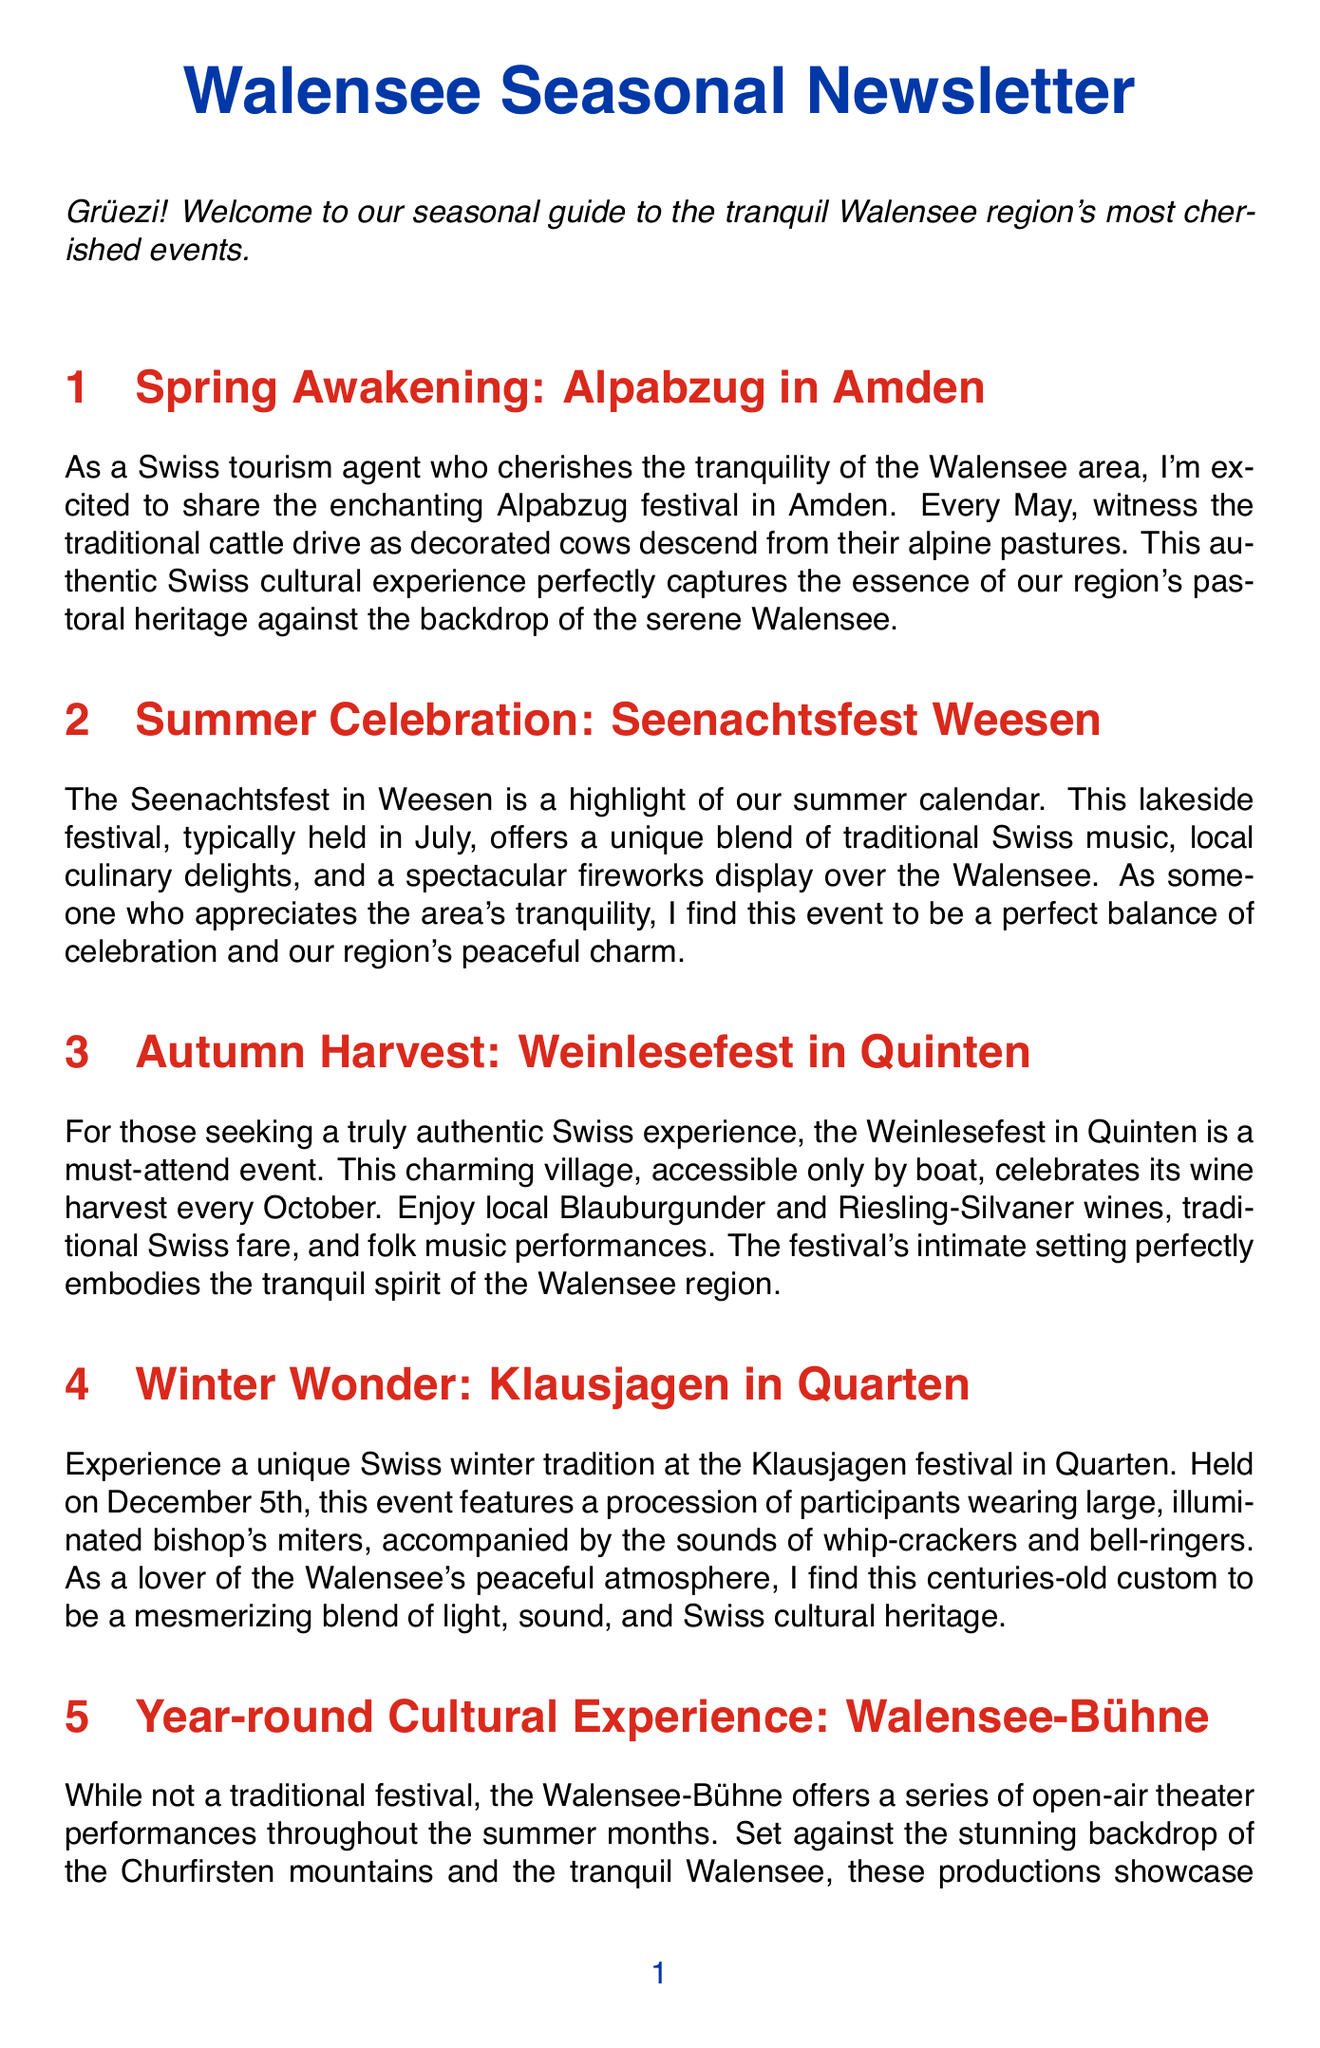What is the title of the spring festival? The title of the spring festival is found in the document under the section "Spring Awakening."
Answer: Alpabzug in Amden In which month is the Seenachtsfest held? The document specifies that the Seenachtsfest is typically held in July during the summer months.
Answer: July What type of food is featured at the Weinlesefest? The document mentions enjoying traditional Swiss fare at the Weinlesefest, indicating the local culinary offerings.
Answer: Traditional Swiss fare When does the Klausjagen festival take place? The chapter on Klausjagen details the date of the festival, which is mentioned explicitly in the text.
Answer: December 5th Which wines are celebrated at the Weinlesefest? The document lists the specific wines served during the event, highlighting the local wine culture.
Answer: Blauburgunder and Riesling-Silvaner What unique visual element is part of the Klausjagen festival? The document describes participants wearing large, illuminated bishop's miters, which is a distinctive aspect of this winter festival.
Answer: Illuminated bishop's miters What type of performances does the Walensee-Bühne feature? The document notes the types of productions showcased at the Walensee-Bühne throughout summer, emphasizing the cultural variety.
Answer: Open-air theater performances What is the backdrop for the Walensee-Bühne performances? The document refers to a specific natural feature that serves as the backdrop for the theater performances.
Answer: Churfirsten mountains and the tranquil Walensee Which festival is accessible only by boat? The document identifies a specific festival that has this unique access requirement, pointing to the exclusivity of the location.
Answer: Weinlesefest in Quinten 